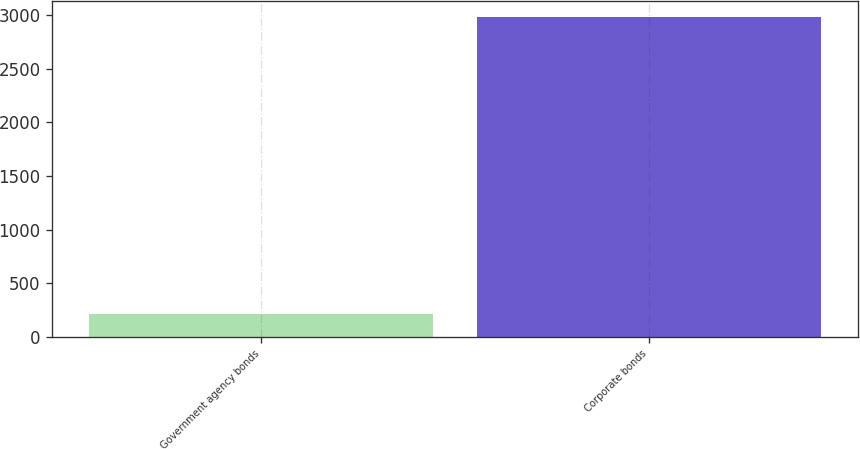Convert chart to OTSL. <chart><loc_0><loc_0><loc_500><loc_500><bar_chart><fcel>Government agency bonds<fcel>Corporate bonds<nl><fcel>215<fcel>2983<nl></chart> 